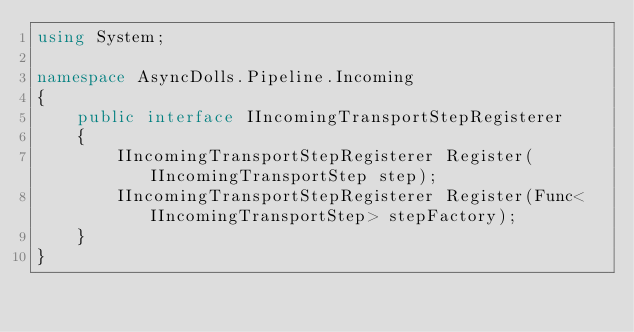<code> <loc_0><loc_0><loc_500><loc_500><_C#_>using System;

namespace AsyncDolls.Pipeline.Incoming
{
    public interface IIncomingTransportStepRegisterer
    {
        IIncomingTransportStepRegisterer Register(IIncomingTransportStep step);
        IIncomingTransportStepRegisterer Register(Func<IIncomingTransportStep> stepFactory);
    }
}</code> 